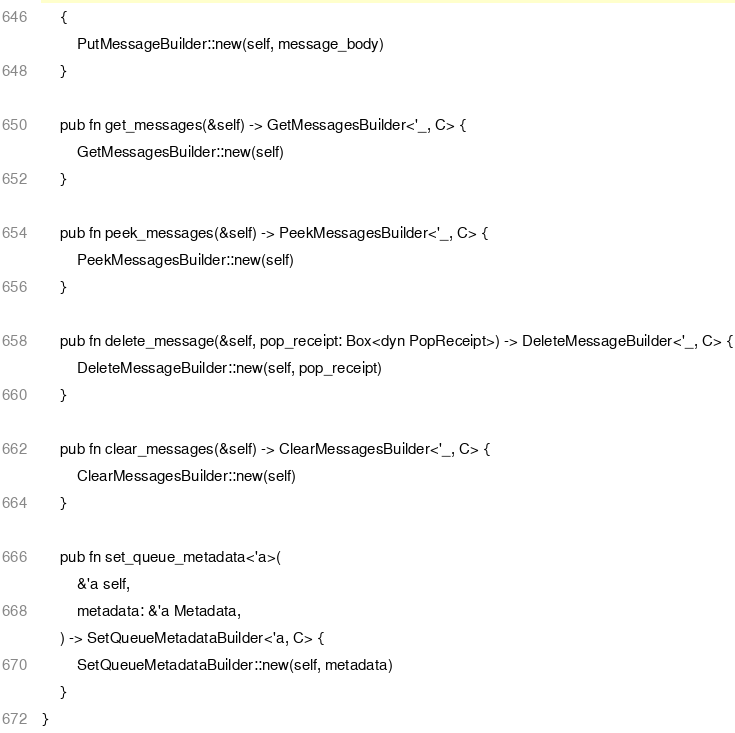Convert code to text. <code><loc_0><loc_0><loc_500><loc_500><_Rust_>    {
        PutMessageBuilder::new(self, message_body)
    }

    pub fn get_messages(&self) -> GetMessagesBuilder<'_, C> {
        GetMessagesBuilder::new(self)
    }

    pub fn peek_messages(&self) -> PeekMessagesBuilder<'_, C> {
        PeekMessagesBuilder::new(self)
    }

    pub fn delete_message(&self, pop_receipt: Box<dyn PopReceipt>) -> DeleteMessageBuilder<'_, C> {
        DeleteMessageBuilder::new(self, pop_receipt)
    }

    pub fn clear_messages(&self) -> ClearMessagesBuilder<'_, C> {
        ClearMessagesBuilder::new(self)
    }

    pub fn set_queue_metadata<'a>(
        &'a self,
        metadata: &'a Metadata,
    ) -> SetQueueMetadataBuilder<'a, C> {
        SetQueueMetadataBuilder::new(self, metadata)
    }
}
</code> 